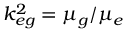Convert formula to latex. <formula><loc_0><loc_0><loc_500><loc_500>k _ { e g } ^ { 2 } = \mu _ { g } / \mu _ { e }</formula> 